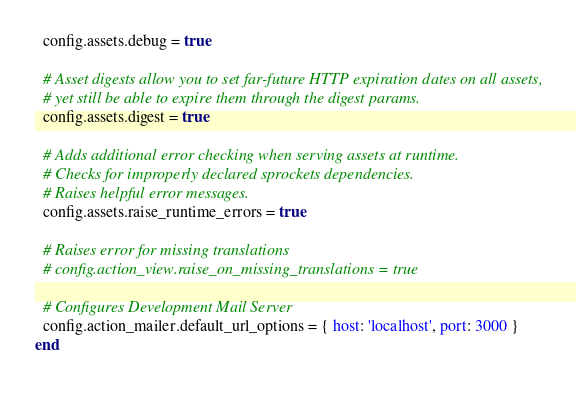<code> <loc_0><loc_0><loc_500><loc_500><_Ruby_>  config.assets.debug = true

  # Asset digests allow you to set far-future HTTP expiration dates on all assets,
  # yet still be able to expire them through the digest params.
  config.assets.digest = true

  # Adds additional error checking when serving assets at runtime.
  # Checks for improperly declared sprockets dependencies.
  # Raises helpful error messages.
  config.assets.raise_runtime_errors = true

  # Raises error for missing translations
  # config.action_view.raise_on_missing_translations = true

  # Configures Development Mail Server
  config.action_mailer.default_url_options = { host: 'localhost', port: 3000 }
end
</code> 